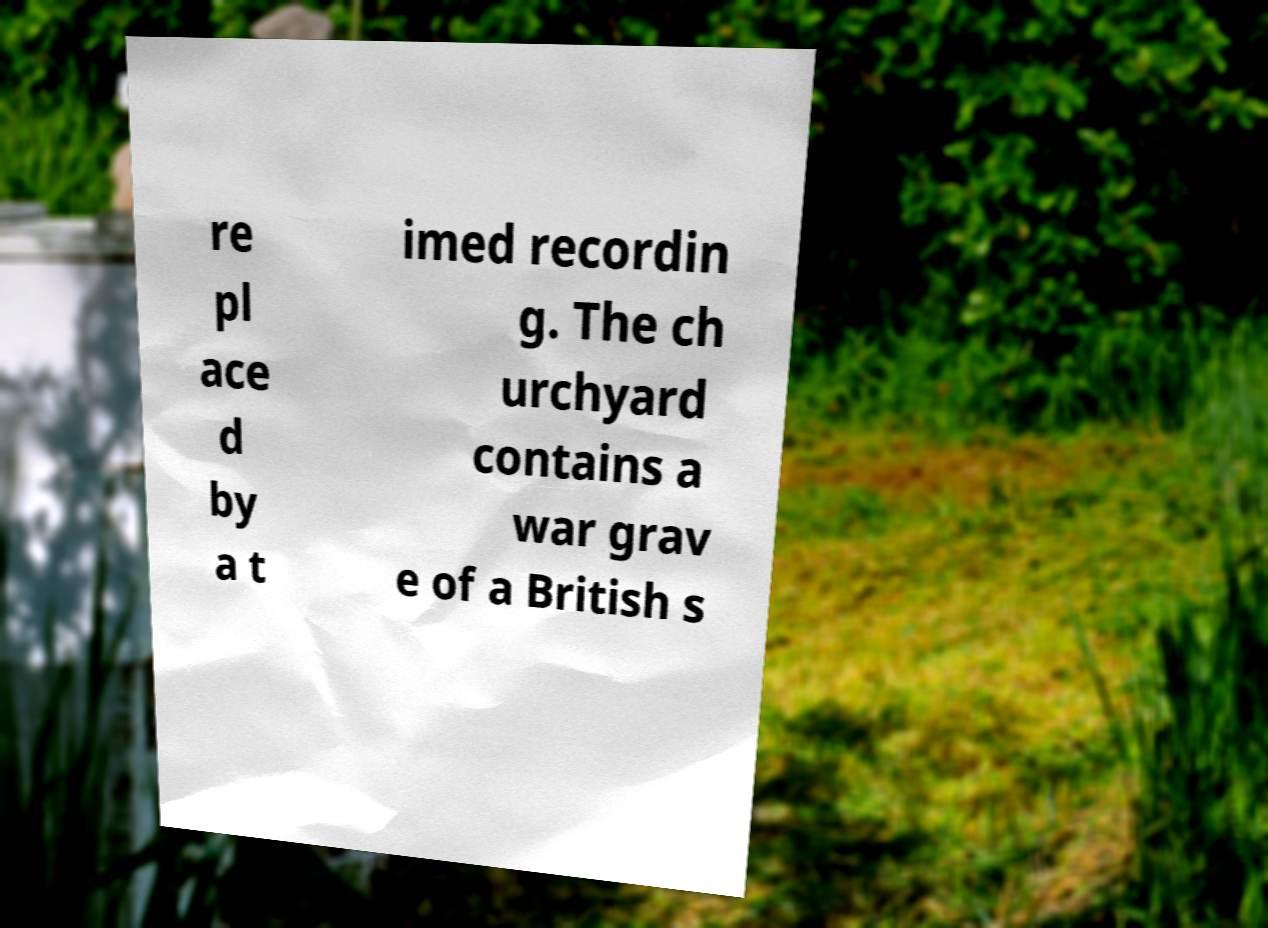I need the written content from this picture converted into text. Can you do that? re pl ace d by a t imed recordin g. The ch urchyard contains a war grav e of a British s 